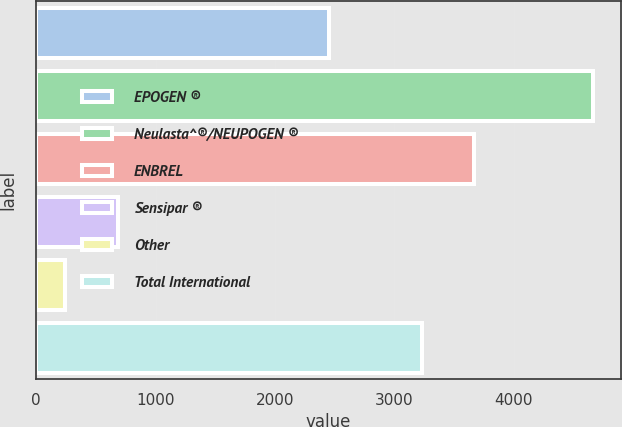Convert chart to OTSL. <chart><loc_0><loc_0><loc_500><loc_500><bar_chart><fcel>EPOGEN ®<fcel>Neulasta^®/NEUPOGEN ®<fcel>ENBREL<fcel>Sensipar ®<fcel>Other<fcel>Total International<nl><fcel>2456<fcel>4659<fcel>3668.9<fcel>681.9<fcel>240<fcel>3227<nl></chart> 